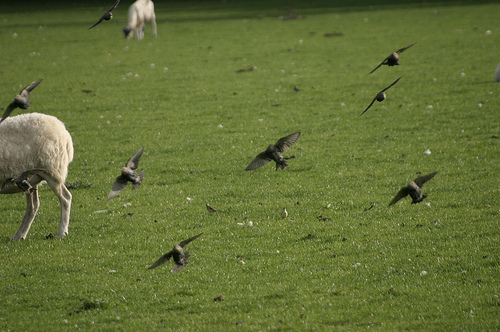Please provide the bounding box coordinate of the region this sentence describes: white animal in the background. A white sheep is visible in the background within the coordinates [0.22, 0.17, 0.43, 0.29], grazing in the meadow. 